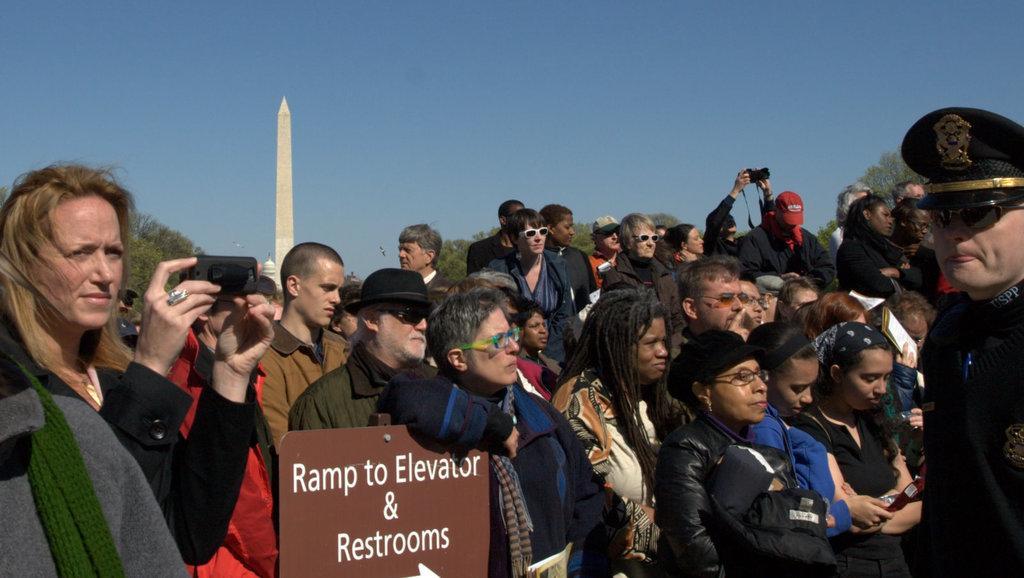Describe this image in one or two sentences. In this image we can see many people and few people holding some objects in their hands. We can see the sky in the image. There is a building in the image. There is a pillar in the image. There are many trees in the image. 